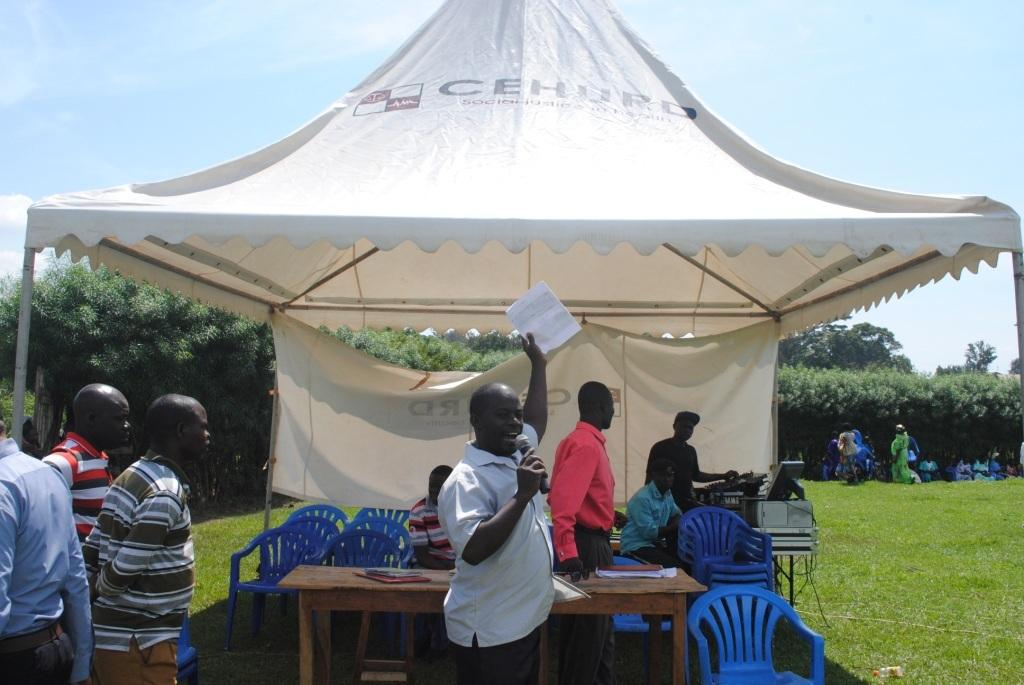How many people are in the image? There is a group of people in the image. Where are the people located in the image? The people are standing under a tent. What is one person holding in the image? One person is holding a mic and paper. What can be seen outside the tent in the image? There are trees visible outside the tent. What is visible in the sky in the image? The sky is visible in the image. How many ladybugs are crawling on the person holding the mic and paper? There are no ladybugs visible in the image; the focus is on the people, tent, trees, and sky. 